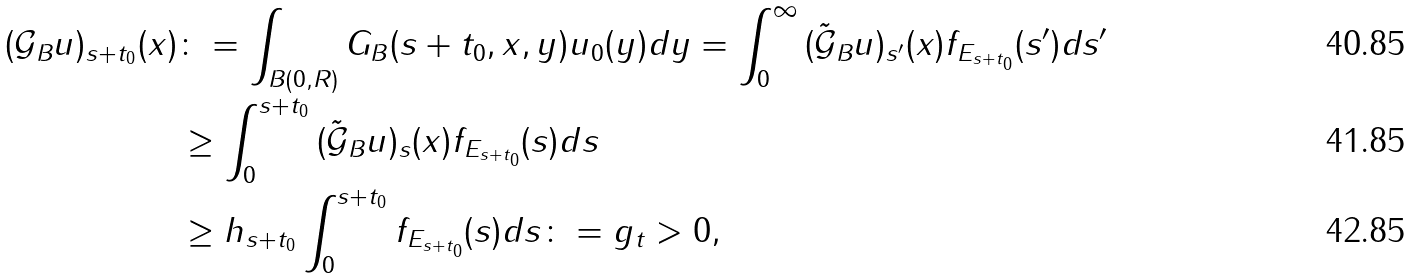<formula> <loc_0><loc_0><loc_500><loc_500>( \mathcal { G } _ { B } u ) _ { s + t _ { 0 } } ( x ) & \colon = \int _ { B ( 0 , R ) } G _ { B } ( s + t _ { 0 } , x , y ) u _ { 0 } ( y ) d y = \int _ { 0 } ^ { \infty } { ( \tilde { \mathcal { G } } _ { B } u ) _ { s ^ { \prime } } } ( x ) f _ { E _ { s + t _ { 0 } } } ( s ^ { \prime } ) d s ^ { \prime } \\ & \geq \int _ { 0 } ^ { s + t _ { 0 } } { ( \tilde { \mathcal { G } } _ { B } u ) _ { s } } ( x ) f _ { E _ { s + t _ { 0 } } } ( s ) d s \\ & \geq h _ { s + t _ { 0 } } \int _ { 0 } ^ { s + t _ { 0 } } f _ { E _ { s + t _ { 0 } } } ( s ) d s \colon = g _ { t } > 0 ,</formula> 